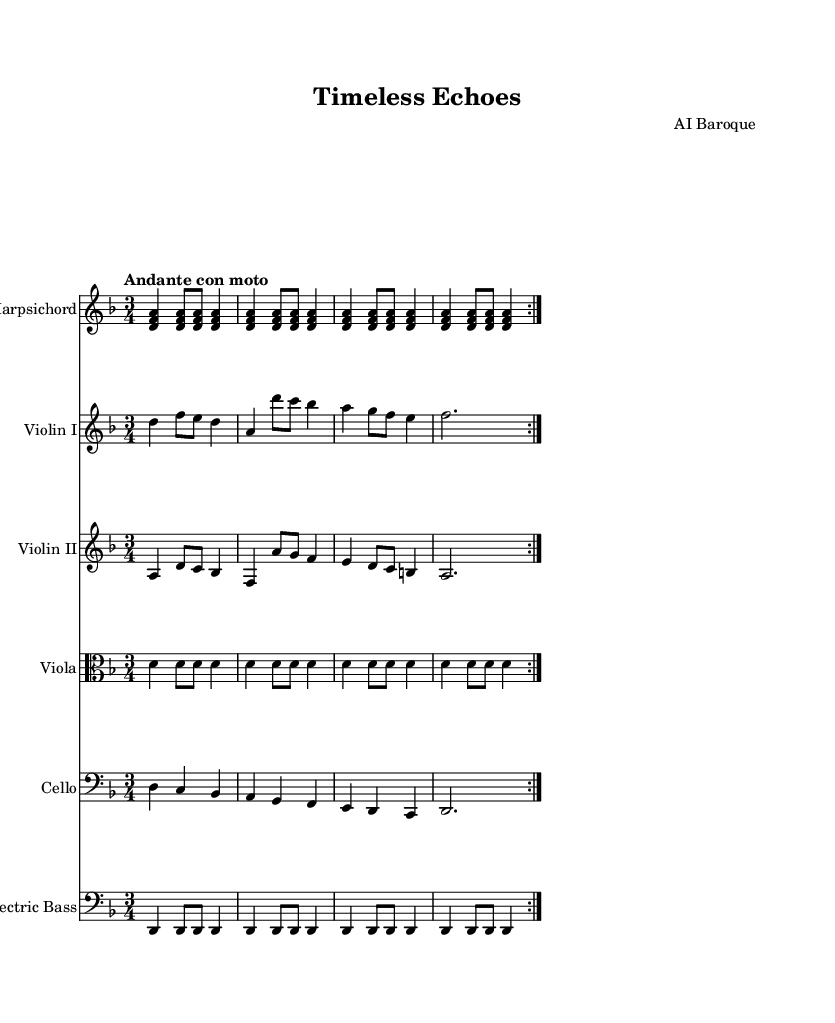What is the key signature of this music? The key signature shows two flats, which indicates D minor. This can be identified by looking at the beginning of the sheet music, where the key signature is notated.
Answer: D minor What is the time signature of this music? The time signature is written at the beginning of the staff, indicated by the '3/4' notation. This means there are three beats in a measure and the quarter note gets the beat.
Answer: 3/4 What is the tempo of this piece? The tempo indication is marked as "Andante con moto," which suggests a moderately slow pace with some motion. This can be found in the tempo marking at the start of the score.
Answer: Andante con moto How many sections are repeated in the harpsichord part? The harpsichord part has a repeat indication, noted by the term 'volta 2', which means the section is played twice. This is stated at the start of the harpsichord's musical line.
Answer: 2 What type of instruments are used in this composition? The score presents five distinct instruments: Harpsichord, Violin I, Violin II, Viola, and Cello, all listed at the beginning of each staff.
Answer: Harpsichord, Violin I, Violin II, Viola, Cello Which instrument plays the bass line in this composition? The bass line is written for both the Cello and the Electric Bass, as seen in the separate staves for each instrument. This provides a harmonic foundation throughout the piece.
Answer: Cello and Electric Bass What stylistic feature suggests this is a Baroque composition? The use of a harpsichord in the instrumentation is a defining characteristic of Baroque music, along with the ornamented melodic lines and the emphasis on counterpoint, as evident in this score.
Answer: Harpsichord 